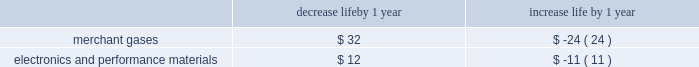Economic useful life is the duration of time an asset is expected to be productively employed by us , which may be less than its physical life .
Assumptions on the following factors , among others , affect the determination of estimated economic useful life : wear and tear , obsolescence , technical standards , contract life , market demand , competitive position , raw material availability , and geographic location .
The estimated economic useful life of an asset is monitored to determine its appropriateness , especially in light of changed business circumstances .
For example , changes in technology , changes in the estimated future demand for products , or excessive wear and tear may result in a shorter estimated useful life than originally anticipated .
In these cases , we would depreciate the remaining net book value over the new estimated remaining life , thereby increasing depreciation expense per year on a prospective basis .
Likewise , if the estimated useful life is increased , the adjustment to the useful life decreases depreciation expense per year on a prospective basis .
We have numerous long-term customer supply contracts , particularly in the gases on-site business within the tonnage gases segment .
These contracts principally have initial contract terms of 15 to 20 years .
There are also long-term customer supply contracts associated with the tonnage gases business within the electronics and performance materials segment .
These contracts principally have initial terms of 10 to 15 years .
Additionally , we have several customer supply contracts within the equipment and energy segment with contract terms that are primarily five to 10 years .
The depreciable lives of assets within this segment can be extended to 20 years for certain redeployable assets .
Depreciable lives of the production assets related to long-term contracts are matched to the contract lives .
Extensions to the contract term of supply frequently occur prior to the expiration of the initial term .
As contract terms are extended , the depreciable life of the remaining net book value of the production assets is adjusted to match the new contract term , as long as it does not exceed the physical life of the asset .
The depreciable lives of production facilities within the merchant gases segment are principally 15 years .
Customer contracts associated with products produced at these types of facilities typically have a much shorter term .
The depreciable lives of production facilities within the electronics and performance materials segment , where there is not an associated long-term supply agreement , range from 10 to 15 years .
These depreciable lives have been determined based on historical experience combined with judgment on future assumptions such as technological advances , potential obsolescence , competitors 2019 actions , etc .
Management monitors its assumptions and may potentially need to adjust depreciable life as circumstances change .
A change in the depreciable life by one year for production facilities within the merchant gases and electronics and performance materials segments for which there is not an associated long-term customer supply agreement would impact annual depreciation expense as summarized below : decrease life by 1 year increase life by 1 year .
Impairment of assets plant and equipment plant and equipment held for use is grouped for impairment testing at the lowest level for which there is identifiable cash flows .
Impairment testing of the asset group occurs whenever events or changes in circumstances indicate that the carrying amount of the assets may not be recoverable .
Such circumstances would include a significant decrease in the market value of a long-lived asset grouping , a significant adverse change in the manner in which the asset grouping is being used or in its physical condition , a history of operating or cash flow losses associated with the use of the asset grouping , or changes in the expected useful life of the long-lived assets .
If such circumstances are determined to exist , an estimate of undiscounted future cash flows produced by that asset group is compared to the carrying value to determine whether impairment exists .
If an asset group is determined to be impaired , the loss is measured based on the difference between the asset group 2019s fair value and its carrying value .
An estimate of the asset group 2019s fair value is based on the discounted value of its estimated cash flows .
Assets to be disposed of by sale are reported at the lower of carrying amount or fair value less cost to sell .
The assumptions underlying cash flow projections represent management 2019s best estimates at the time of the impairment review .
Factors that management must estimate include industry and market conditions , sales volume and prices , costs to produce , inflation , etc .
Changes in key assumptions or actual conditions that differ from estimates could result in an impairment charge .
We use reasonable and supportable assumptions when performing .
Considering the contract terms of 10 years , what will be the total expense with the depreciation of the electronics and performance materials segment?\\n? 
Rationale: it is the number of years of the contract multiplied by the increased life by year .
Computations: (10 * 11)
Answer: 110.0. 